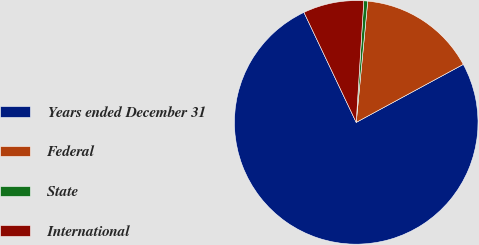Convert chart. <chart><loc_0><loc_0><loc_500><loc_500><pie_chart><fcel>Years ended December 31<fcel>Federal<fcel>State<fcel>International<nl><fcel>75.84%<fcel>15.59%<fcel>0.52%<fcel>8.05%<nl></chart> 